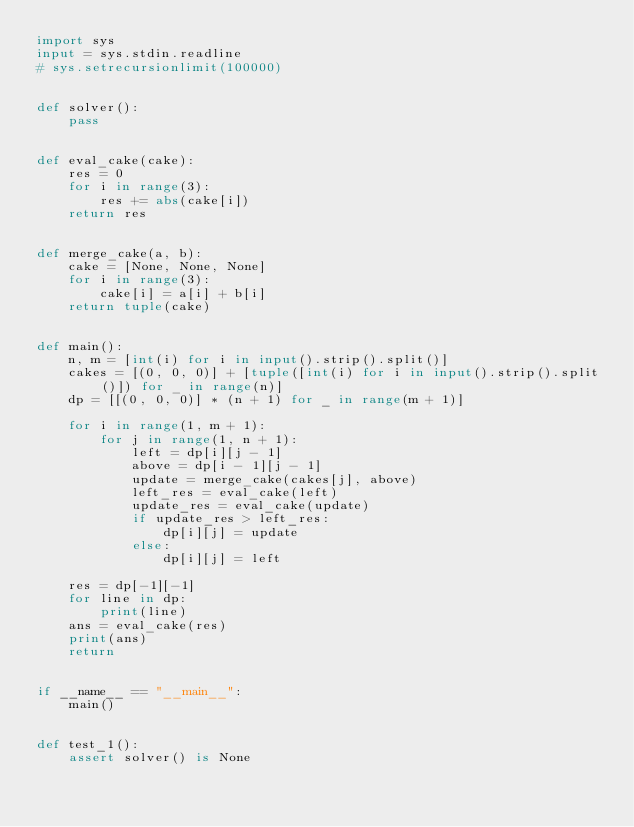<code> <loc_0><loc_0><loc_500><loc_500><_Python_>import sys
input = sys.stdin.readline
# sys.setrecursionlimit(100000)


def solver():
    pass


def eval_cake(cake):
    res = 0
    for i in range(3):
        res += abs(cake[i])
    return res


def merge_cake(a, b):
    cake = [None, None, None]
    for i in range(3):
        cake[i] = a[i] + b[i]
    return tuple(cake)


def main():
    n, m = [int(i) for i in input().strip().split()]
    cakes = [(0, 0, 0)] + [tuple([int(i) for i in input().strip().split()]) for _ in range(n)]
    dp = [[(0, 0, 0)] * (n + 1) for _ in range(m + 1)]

    for i in range(1, m + 1):
        for j in range(1, n + 1):
            left = dp[i][j - 1]
            above = dp[i - 1][j - 1]
            update = merge_cake(cakes[j], above)
            left_res = eval_cake(left)
            update_res = eval_cake(update)
            if update_res > left_res:
                dp[i][j] = update
            else:
                dp[i][j] = left

    res = dp[-1][-1]
    for line in dp:
        print(line)
    ans = eval_cake(res)
    print(ans)
    return


if __name__ == "__main__":
    main()


def test_1():
    assert solver() is None
</code> 